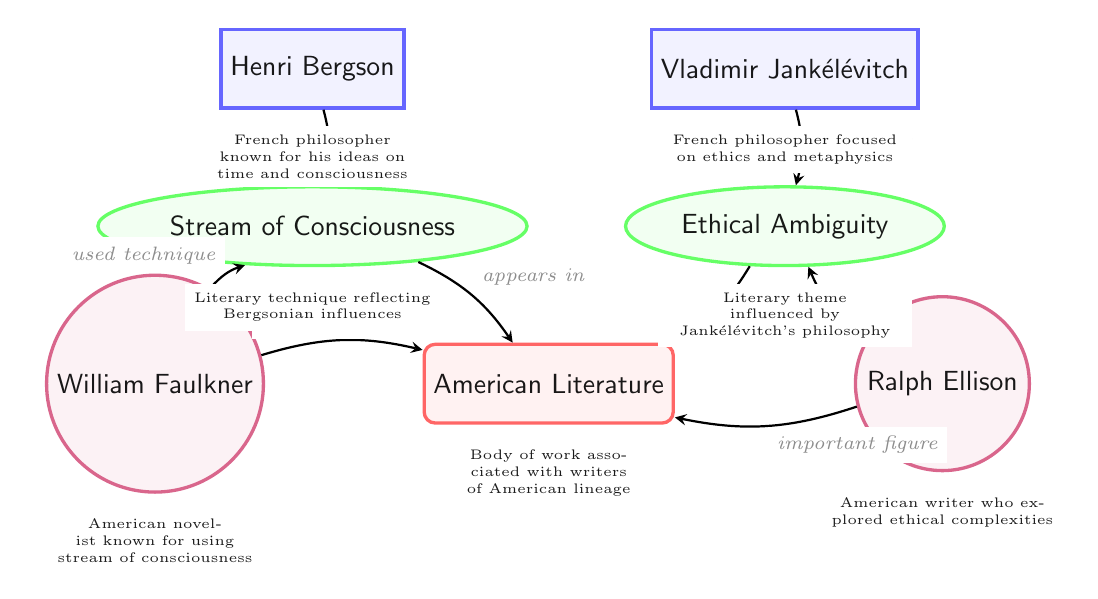What are the two philosophical figures depicted in the diagram? The diagram displays Henri Bergson and Vladimir Jankélévitch as the two philosophical figures.
Answer: Henri Bergson, Vladimir Jankélévitch Which literary technique is influenced by Bergson? According to the diagram, the Stream of Consciousness is the literary technique influenced by Bergson's philosophy.
Answer: Stream of Consciousness How many authors are represented in the diagram? The diagram shows a total of two authors: William Faulkner and Ralph Ellison.
Answer: 2 What theme explored by Ellison is influenced by Jankélévitch? The Ethical Ambiguity theme, as shown in the diagram, is the one influenced by Jankélévitch's philosophy, explored by Ralph Ellison.
Answer: Ethical Ambiguity Which author is associated with the Stream of Consciousness technique? The diagram indicates that William Faulkner is the author associated with using the Stream of Consciousness technique.
Answer: William Faulkner What is the relationship between Jankélévitch and Ethical Ambiguity? In the diagram, it is shown that Jankélévitch influenced the concept of Ethical Ambiguity.
Answer: influenced How does the Stream of Consciousness appear in the context of American Literature? The diagram indicates that the Stream of Consciousness appears in American Literature as a result of Bergson's influence.
Answer: appears in Which philosopher is primarily known for ideas on time and consciousness? The diagram clearly identifies Henri Bergson as primarily known for his ideas on time and consciousness.
Answer: Henri Bergson Who is depicted as an important figure in American Literature alongside Faulkner? Ralph Ellison is depicted as another important figure in American Literature in the diagram, alongside Faulkner.
Answer: Ralph Ellison 